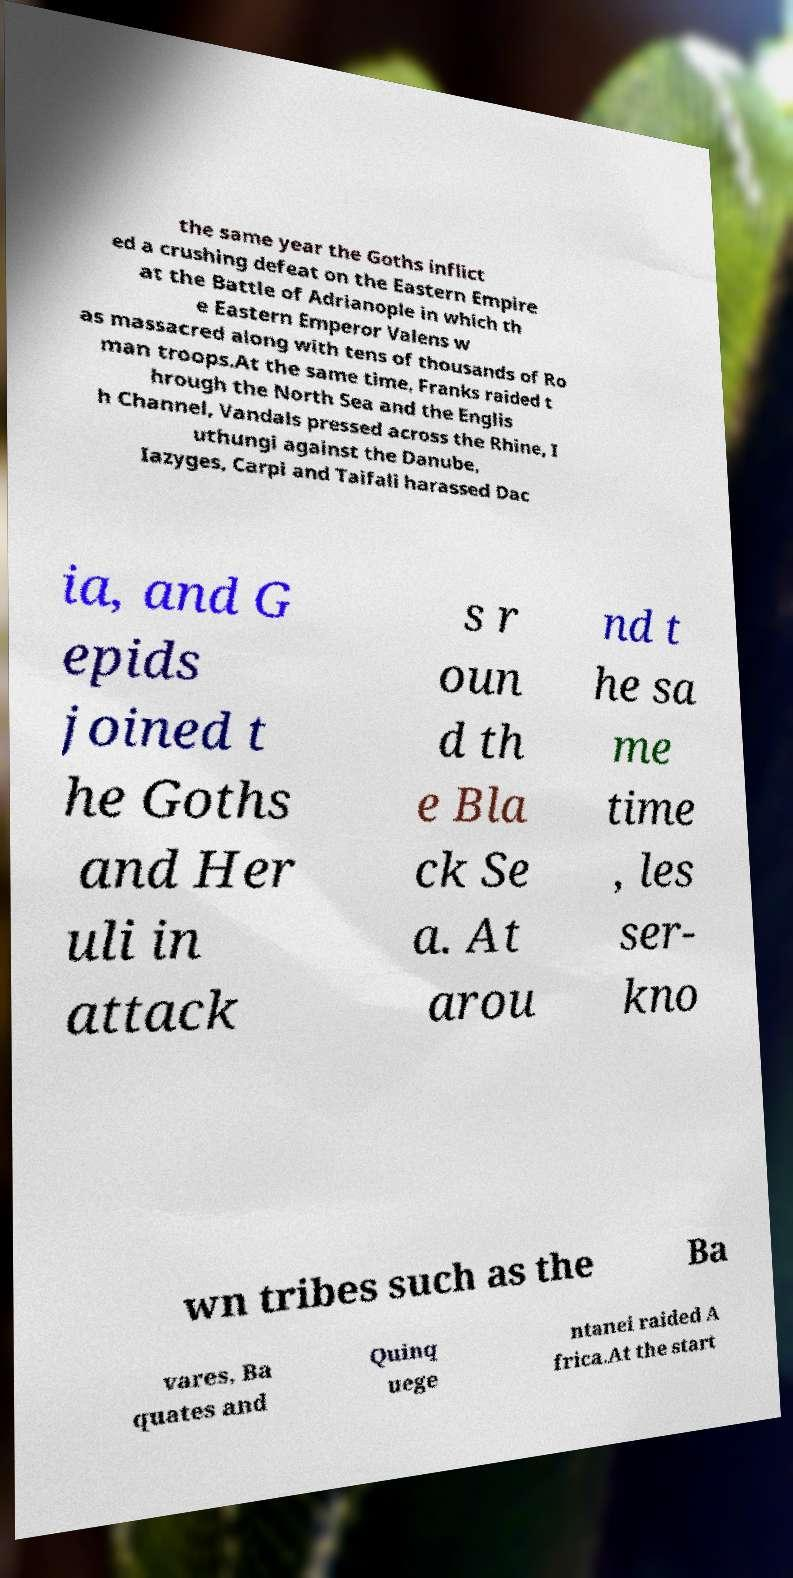I need the written content from this picture converted into text. Can you do that? the same year the Goths inflict ed a crushing defeat on the Eastern Empire at the Battle of Adrianople in which th e Eastern Emperor Valens w as massacred along with tens of thousands of Ro man troops.At the same time, Franks raided t hrough the North Sea and the Englis h Channel, Vandals pressed across the Rhine, I uthungi against the Danube, Iazyges, Carpi and Taifali harassed Dac ia, and G epids joined t he Goths and Her uli in attack s r oun d th e Bla ck Se a. At arou nd t he sa me time , les ser- kno wn tribes such as the Ba vares, Ba quates and Quinq uege ntanei raided A frica.At the start 